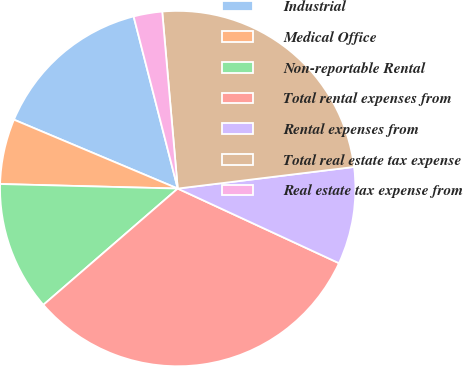Convert chart. <chart><loc_0><loc_0><loc_500><loc_500><pie_chart><fcel>Industrial<fcel>Medical Office<fcel>Non-reportable Rental<fcel>Total rental expenses from<fcel>Rental expenses from<fcel>Total real estate tax expense<fcel>Real estate tax expense from<nl><fcel>14.67%<fcel>5.93%<fcel>11.76%<fcel>31.75%<fcel>8.84%<fcel>24.45%<fcel>2.6%<nl></chart> 